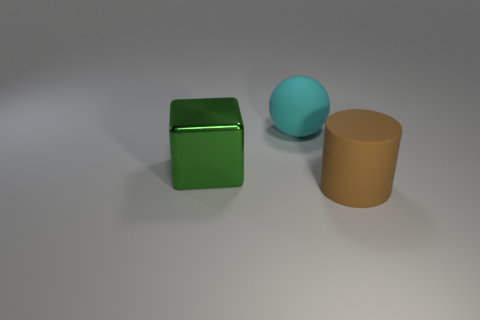How many objects are both on the right side of the cyan sphere and left of the rubber ball?
Provide a short and direct response. 0. There is a object that is behind the green block; what is it made of?
Ensure brevity in your answer.  Rubber. The cylinder that is made of the same material as the cyan object is what size?
Keep it short and to the point. Large. Are there any matte cylinders in front of the cylinder?
Your response must be concise. No. There is a big metal cube; is its color the same as the thing on the right side of the large cyan matte thing?
Keep it short and to the point. No. Is the big matte cylinder the same color as the big cube?
Make the answer very short. No. Is the number of gray objects less than the number of large green things?
Offer a very short reply. Yes. What number of other things are the same color as the large metallic thing?
Your answer should be compact. 0. What number of big rubber balls are there?
Your answer should be very brief. 1. Are there fewer big cyan things that are to the right of the big cyan rubber thing than purple cubes?
Make the answer very short. No. 